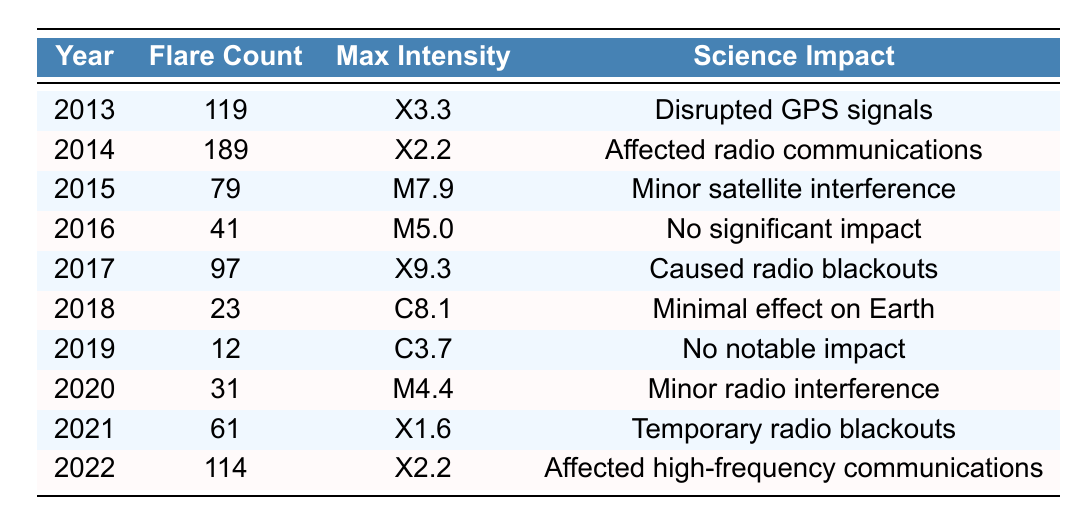What was the maximum intensity of solar flares in 2014? From the table, the maximum intensity for 2014 is listed as X2.2.
Answer: X2.2 How many solar flares occurred in the year with the highest count? By examining the table, 2014 has the highest flare count of 189.
Answer: 189 What was the average count of solar flares from 2013 to 2022? The total flare counts from 2013 to 2022 are 119 + 189 + 79 + 41 + 97 + 23 + 12 + 31 + 61 + 114 =  725. There are 10 years, so the average is 725/10 = 72.5.
Answer: 72.5 In which year did solar flares have minimal effects on Earth? In 2018, it is reported that the science impact was "Minimal effect on Earth."
Answer: 2018 Did any year have more than 100 solar flares? Yes, the years 2013, 2014, and 2022 all had more than 100 solar flares.
Answer: Yes What is the difference in flare count between the years with the highest (2014) and lowest (2019) counts? The flare count for 2014 is 189 and for 2019 is 12. The difference is 189 - 12 = 177.
Answer: 177 Which year had a max intensity of X9.3? The year 2017 recorded a maximum intensity of X9.3.
Answer: 2017 How many years had a maximum intensity classified as M? Looking at the table, the years with maximum intensity classified as M are 2015, 2016, and 2020, totaling 3 years.
Answer: 3 Was there any year that reported "No notable impact"? Yes, 2019 reported "No notable impact."
Answer: Yes Which year between 2013 and 2022 had the lowest solar flare count? By reviewing the table, the lowest solar flare count was in 2019 with 12 flares.
Answer: 2019 